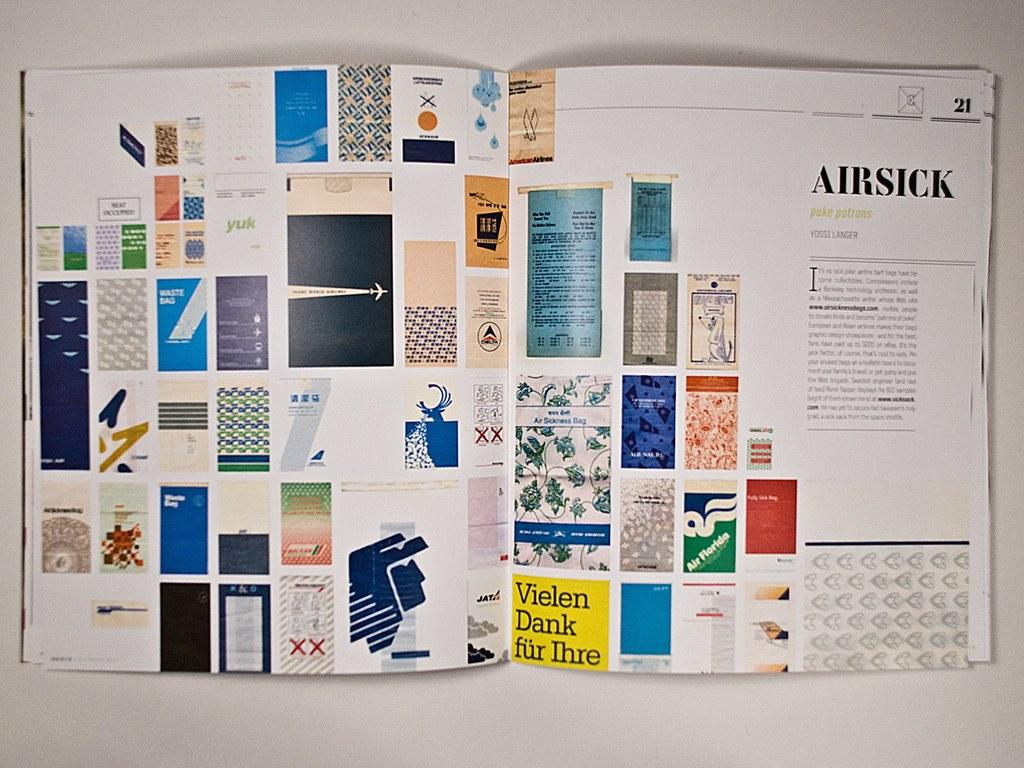<image>
Give a short and clear explanation of the subsequent image. An opened book shows details about airsick puke patrons. 